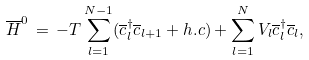Convert formula to latex. <formula><loc_0><loc_0><loc_500><loc_500>\overline { H } ^ { 0 } \, = \, - T \sum _ { l = 1 } ^ { N - 1 } ( \overline { c } ^ { \dagger } _ { l } \overline { c } _ { l + 1 } + h . c ) + \sum _ { l = 1 } ^ { N } V _ { l } \overline { c } ^ { \dagger } _ { l } \overline { c } _ { l } ,</formula> 